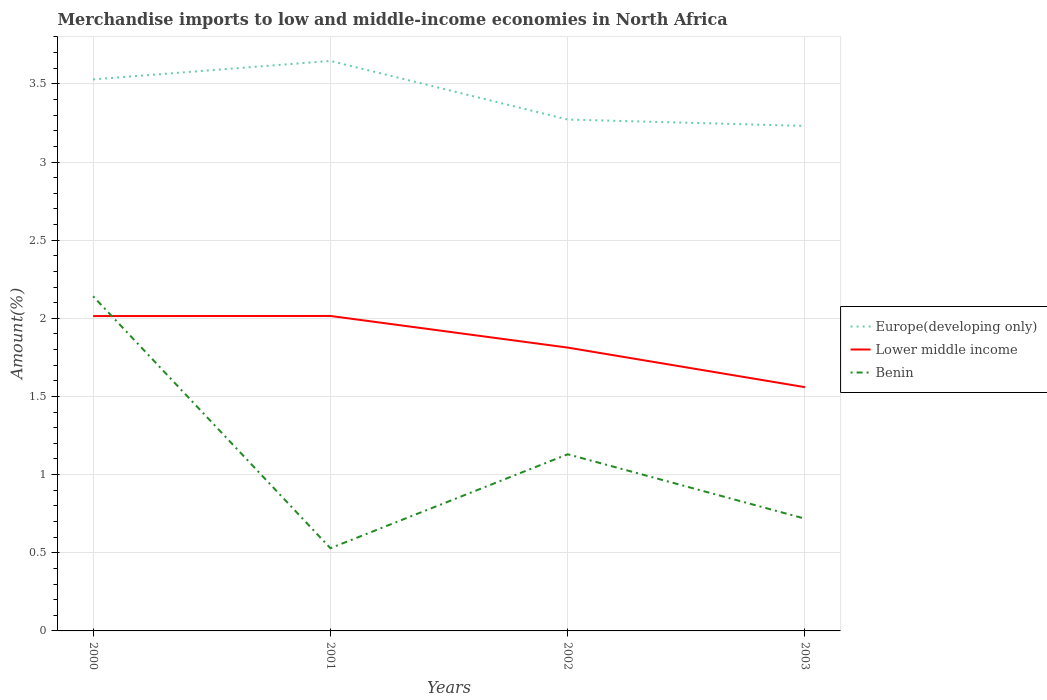How many different coloured lines are there?
Keep it short and to the point. 3. Does the line corresponding to Europe(developing only) intersect with the line corresponding to Lower middle income?
Provide a succinct answer. No. Is the number of lines equal to the number of legend labels?
Provide a succinct answer. Yes. Across all years, what is the maximum percentage of amount earned from merchandise imports in Europe(developing only)?
Your answer should be compact. 3.23. What is the total percentage of amount earned from merchandise imports in Lower middle income in the graph?
Your answer should be compact. 0.2. What is the difference between the highest and the second highest percentage of amount earned from merchandise imports in Lower middle income?
Your answer should be very brief. 0.46. Is the percentage of amount earned from merchandise imports in Lower middle income strictly greater than the percentage of amount earned from merchandise imports in Benin over the years?
Make the answer very short. No. How many lines are there?
Your answer should be compact. 3. Are the values on the major ticks of Y-axis written in scientific E-notation?
Offer a terse response. No. Where does the legend appear in the graph?
Your answer should be compact. Center right. What is the title of the graph?
Your answer should be compact. Merchandise imports to low and middle-income economies in North Africa. What is the label or title of the X-axis?
Offer a very short reply. Years. What is the label or title of the Y-axis?
Provide a short and direct response. Amount(%). What is the Amount(%) in Europe(developing only) in 2000?
Provide a short and direct response. 3.53. What is the Amount(%) in Lower middle income in 2000?
Make the answer very short. 2.01. What is the Amount(%) of Benin in 2000?
Offer a very short reply. 2.14. What is the Amount(%) of Europe(developing only) in 2001?
Provide a short and direct response. 3.65. What is the Amount(%) of Lower middle income in 2001?
Your response must be concise. 2.02. What is the Amount(%) of Benin in 2001?
Provide a succinct answer. 0.53. What is the Amount(%) of Europe(developing only) in 2002?
Keep it short and to the point. 3.27. What is the Amount(%) in Lower middle income in 2002?
Provide a short and direct response. 1.81. What is the Amount(%) of Benin in 2002?
Keep it short and to the point. 1.13. What is the Amount(%) in Europe(developing only) in 2003?
Your answer should be very brief. 3.23. What is the Amount(%) of Lower middle income in 2003?
Give a very brief answer. 1.56. What is the Amount(%) of Benin in 2003?
Offer a terse response. 0.72. Across all years, what is the maximum Amount(%) in Europe(developing only)?
Keep it short and to the point. 3.65. Across all years, what is the maximum Amount(%) in Lower middle income?
Provide a succinct answer. 2.02. Across all years, what is the maximum Amount(%) in Benin?
Ensure brevity in your answer.  2.14. Across all years, what is the minimum Amount(%) in Europe(developing only)?
Keep it short and to the point. 3.23. Across all years, what is the minimum Amount(%) in Lower middle income?
Give a very brief answer. 1.56. Across all years, what is the minimum Amount(%) of Benin?
Offer a very short reply. 0.53. What is the total Amount(%) in Europe(developing only) in the graph?
Your answer should be very brief. 13.68. What is the total Amount(%) in Lower middle income in the graph?
Your response must be concise. 7.4. What is the total Amount(%) of Benin in the graph?
Your answer should be very brief. 4.52. What is the difference between the Amount(%) of Europe(developing only) in 2000 and that in 2001?
Offer a terse response. -0.12. What is the difference between the Amount(%) in Lower middle income in 2000 and that in 2001?
Your answer should be compact. -0. What is the difference between the Amount(%) in Benin in 2000 and that in 2001?
Make the answer very short. 1.61. What is the difference between the Amount(%) in Europe(developing only) in 2000 and that in 2002?
Give a very brief answer. 0.26. What is the difference between the Amount(%) of Lower middle income in 2000 and that in 2002?
Keep it short and to the point. 0.2. What is the difference between the Amount(%) of Benin in 2000 and that in 2002?
Offer a very short reply. 1.01. What is the difference between the Amount(%) of Europe(developing only) in 2000 and that in 2003?
Keep it short and to the point. 0.3. What is the difference between the Amount(%) of Lower middle income in 2000 and that in 2003?
Your response must be concise. 0.46. What is the difference between the Amount(%) of Benin in 2000 and that in 2003?
Your response must be concise. 1.42. What is the difference between the Amount(%) in Europe(developing only) in 2001 and that in 2002?
Make the answer very short. 0.37. What is the difference between the Amount(%) of Lower middle income in 2001 and that in 2002?
Offer a very short reply. 0.2. What is the difference between the Amount(%) of Benin in 2001 and that in 2002?
Provide a succinct answer. -0.6. What is the difference between the Amount(%) in Europe(developing only) in 2001 and that in 2003?
Make the answer very short. 0.42. What is the difference between the Amount(%) in Lower middle income in 2001 and that in 2003?
Provide a succinct answer. 0.46. What is the difference between the Amount(%) in Benin in 2001 and that in 2003?
Provide a succinct answer. -0.19. What is the difference between the Amount(%) in Europe(developing only) in 2002 and that in 2003?
Keep it short and to the point. 0.04. What is the difference between the Amount(%) of Lower middle income in 2002 and that in 2003?
Offer a very short reply. 0.25. What is the difference between the Amount(%) in Benin in 2002 and that in 2003?
Your answer should be compact. 0.41. What is the difference between the Amount(%) in Europe(developing only) in 2000 and the Amount(%) in Lower middle income in 2001?
Keep it short and to the point. 1.51. What is the difference between the Amount(%) of Europe(developing only) in 2000 and the Amount(%) of Benin in 2001?
Offer a terse response. 3. What is the difference between the Amount(%) in Lower middle income in 2000 and the Amount(%) in Benin in 2001?
Give a very brief answer. 1.49. What is the difference between the Amount(%) of Europe(developing only) in 2000 and the Amount(%) of Lower middle income in 2002?
Your answer should be very brief. 1.72. What is the difference between the Amount(%) in Europe(developing only) in 2000 and the Amount(%) in Benin in 2002?
Your answer should be compact. 2.4. What is the difference between the Amount(%) of Lower middle income in 2000 and the Amount(%) of Benin in 2002?
Provide a succinct answer. 0.88. What is the difference between the Amount(%) in Europe(developing only) in 2000 and the Amount(%) in Lower middle income in 2003?
Make the answer very short. 1.97. What is the difference between the Amount(%) in Europe(developing only) in 2000 and the Amount(%) in Benin in 2003?
Provide a succinct answer. 2.81. What is the difference between the Amount(%) in Lower middle income in 2000 and the Amount(%) in Benin in 2003?
Your answer should be compact. 1.3. What is the difference between the Amount(%) of Europe(developing only) in 2001 and the Amount(%) of Lower middle income in 2002?
Offer a very short reply. 1.83. What is the difference between the Amount(%) of Europe(developing only) in 2001 and the Amount(%) of Benin in 2002?
Your response must be concise. 2.52. What is the difference between the Amount(%) of Lower middle income in 2001 and the Amount(%) of Benin in 2002?
Your answer should be very brief. 0.88. What is the difference between the Amount(%) in Europe(developing only) in 2001 and the Amount(%) in Lower middle income in 2003?
Offer a very short reply. 2.09. What is the difference between the Amount(%) of Europe(developing only) in 2001 and the Amount(%) of Benin in 2003?
Make the answer very short. 2.93. What is the difference between the Amount(%) of Lower middle income in 2001 and the Amount(%) of Benin in 2003?
Keep it short and to the point. 1.3. What is the difference between the Amount(%) in Europe(developing only) in 2002 and the Amount(%) in Lower middle income in 2003?
Offer a very short reply. 1.71. What is the difference between the Amount(%) of Europe(developing only) in 2002 and the Amount(%) of Benin in 2003?
Keep it short and to the point. 2.55. What is the difference between the Amount(%) of Lower middle income in 2002 and the Amount(%) of Benin in 2003?
Your response must be concise. 1.09. What is the average Amount(%) of Europe(developing only) per year?
Offer a very short reply. 3.42. What is the average Amount(%) of Lower middle income per year?
Your response must be concise. 1.85. What is the average Amount(%) of Benin per year?
Your answer should be very brief. 1.13. In the year 2000, what is the difference between the Amount(%) in Europe(developing only) and Amount(%) in Lower middle income?
Offer a terse response. 1.51. In the year 2000, what is the difference between the Amount(%) of Europe(developing only) and Amount(%) of Benin?
Your answer should be very brief. 1.39. In the year 2000, what is the difference between the Amount(%) in Lower middle income and Amount(%) in Benin?
Make the answer very short. -0.13. In the year 2001, what is the difference between the Amount(%) of Europe(developing only) and Amount(%) of Lower middle income?
Offer a terse response. 1.63. In the year 2001, what is the difference between the Amount(%) of Europe(developing only) and Amount(%) of Benin?
Make the answer very short. 3.12. In the year 2001, what is the difference between the Amount(%) of Lower middle income and Amount(%) of Benin?
Your answer should be compact. 1.49. In the year 2002, what is the difference between the Amount(%) in Europe(developing only) and Amount(%) in Lower middle income?
Offer a terse response. 1.46. In the year 2002, what is the difference between the Amount(%) of Europe(developing only) and Amount(%) of Benin?
Keep it short and to the point. 2.14. In the year 2002, what is the difference between the Amount(%) of Lower middle income and Amount(%) of Benin?
Your answer should be compact. 0.68. In the year 2003, what is the difference between the Amount(%) of Europe(developing only) and Amount(%) of Lower middle income?
Ensure brevity in your answer.  1.67. In the year 2003, what is the difference between the Amount(%) of Europe(developing only) and Amount(%) of Benin?
Your answer should be compact. 2.51. In the year 2003, what is the difference between the Amount(%) of Lower middle income and Amount(%) of Benin?
Keep it short and to the point. 0.84. What is the ratio of the Amount(%) in Europe(developing only) in 2000 to that in 2001?
Offer a very short reply. 0.97. What is the ratio of the Amount(%) in Lower middle income in 2000 to that in 2001?
Your response must be concise. 1. What is the ratio of the Amount(%) in Benin in 2000 to that in 2001?
Provide a short and direct response. 4.05. What is the ratio of the Amount(%) of Europe(developing only) in 2000 to that in 2002?
Provide a short and direct response. 1.08. What is the ratio of the Amount(%) in Lower middle income in 2000 to that in 2002?
Keep it short and to the point. 1.11. What is the ratio of the Amount(%) of Benin in 2000 to that in 2002?
Ensure brevity in your answer.  1.89. What is the ratio of the Amount(%) of Europe(developing only) in 2000 to that in 2003?
Provide a succinct answer. 1.09. What is the ratio of the Amount(%) in Lower middle income in 2000 to that in 2003?
Provide a succinct answer. 1.29. What is the ratio of the Amount(%) of Benin in 2000 to that in 2003?
Your answer should be very brief. 2.98. What is the ratio of the Amount(%) in Europe(developing only) in 2001 to that in 2002?
Your answer should be compact. 1.11. What is the ratio of the Amount(%) of Lower middle income in 2001 to that in 2002?
Offer a very short reply. 1.11. What is the ratio of the Amount(%) of Benin in 2001 to that in 2002?
Your answer should be compact. 0.47. What is the ratio of the Amount(%) in Europe(developing only) in 2001 to that in 2003?
Make the answer very short. 1.13. What is the ratio of the Amount(%) in Lower middle income in 2001 to that in 2003?
Make the answer very short. 1.29. What is the ratio of the Amount(%) of Benin in 2001 to that in 2003?
Make the answer very short. 0.74. What is the ratio of the Amount(%) of Europe(developing only) in 2002 to that in 2003?
Your answer should be compact. 1.01. What is the ratio of the Amount(%) of Lower middle income in 2002 to that in 2003?
Your response must be concise. 1.16. What is the ratio of the Amount(%) in Benin in 2002 to that in 2003?
Provide a succinct answer. 1.57. What is the difference between the highest and the second highest Amount(%) of Europe(developing only)?
Ensure brevity in your answer.  0.12. What is the difference between the highest and the second highest Amount(%) of Lower middle income?
Ensure brevity in your answer.  0. What is the difference between the highest and the second highest Amount(%) of Benin?
Offer a terse response. 1.01. What is the difference between the highest and the lowest Amount(%) in Europe(developing only)?
Offer a very short reply. 0.42. What is the difference between the highest and the lowest Amount(%) in Lower middle income?
Provide a succinct answer. 0.46. What is the difference between the highest and the lowest Amount(%) in Benin?
Your answer should be compact. 1.61. 